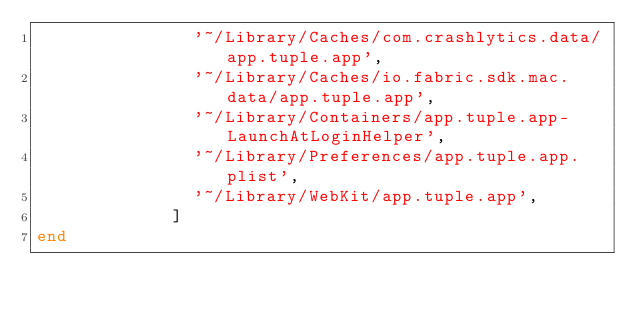<code> <loc_0><loc_0><loc_500><loc_500><_Ruby_>               '~/Library/Caches/com.crashlytics.data/app.tuple.app',
               '~/Library/Caches/io.fabric.sdk.mac.data/app.tuple.app',
               '~/Library/Containers/app.tuple.app-LaunchAtLoginHelper',
               '~/Library/Preferences/app.tuple.app.plist',
               '~/Library/WebKit/app.tuple.app',
             ]
end
</code> 